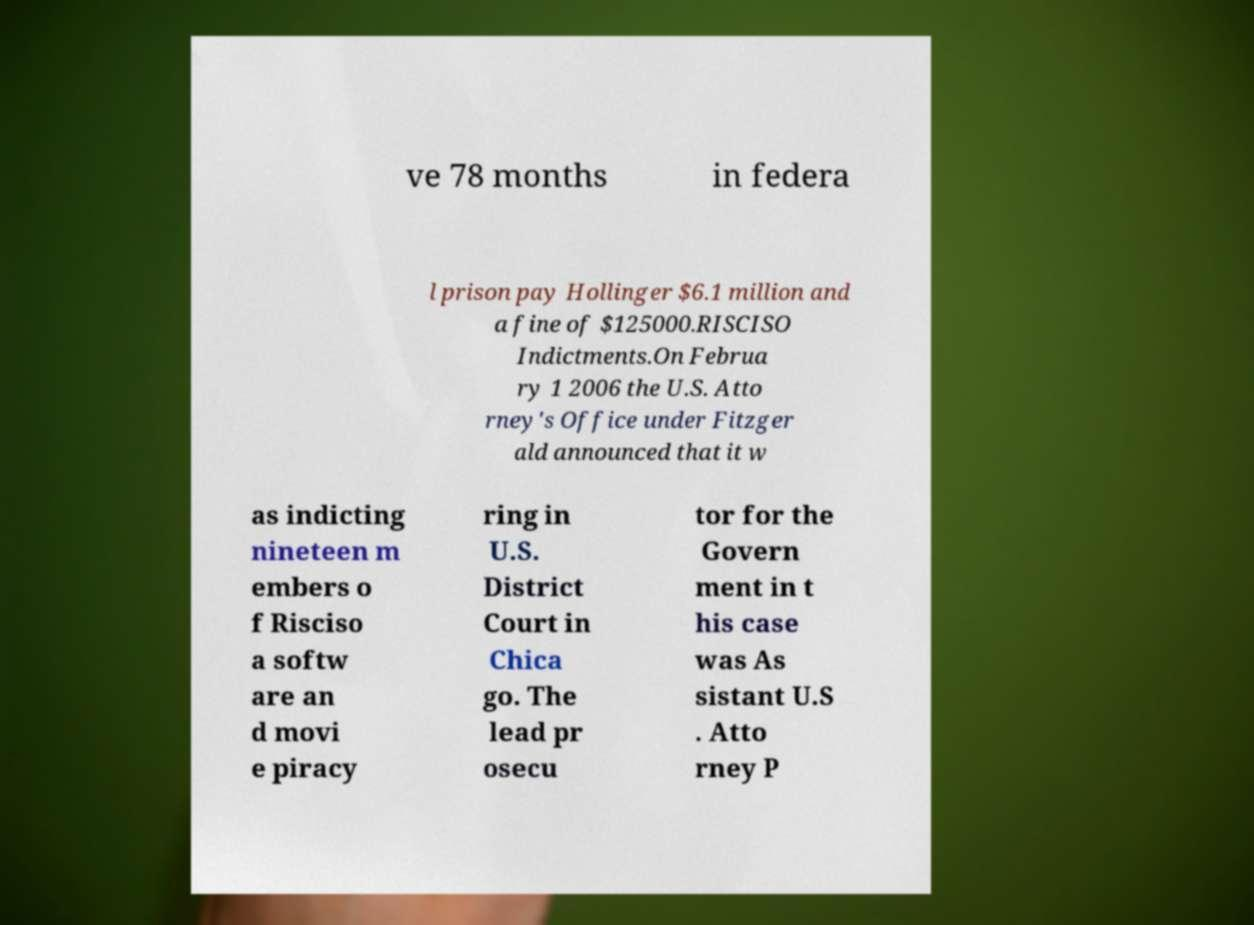There's text embedded in this image that I need extracted. Can you transcribe it verbatim? ve 78 months in federa l prison pay Hollinger $6.1 million and a fine of $125000.RISCISO Indictments.On Februa ry 1 2006 the U.S. Atto rney's Office under Fitzger ald announced that it w as indicting nineteen m embers o f Risciso a softw are an d movi e piracy ring in U.S. District Court in Chica go. The lead pr osecu tor for the Govern ment in t his case was As sistant U.S . Atto rney P 